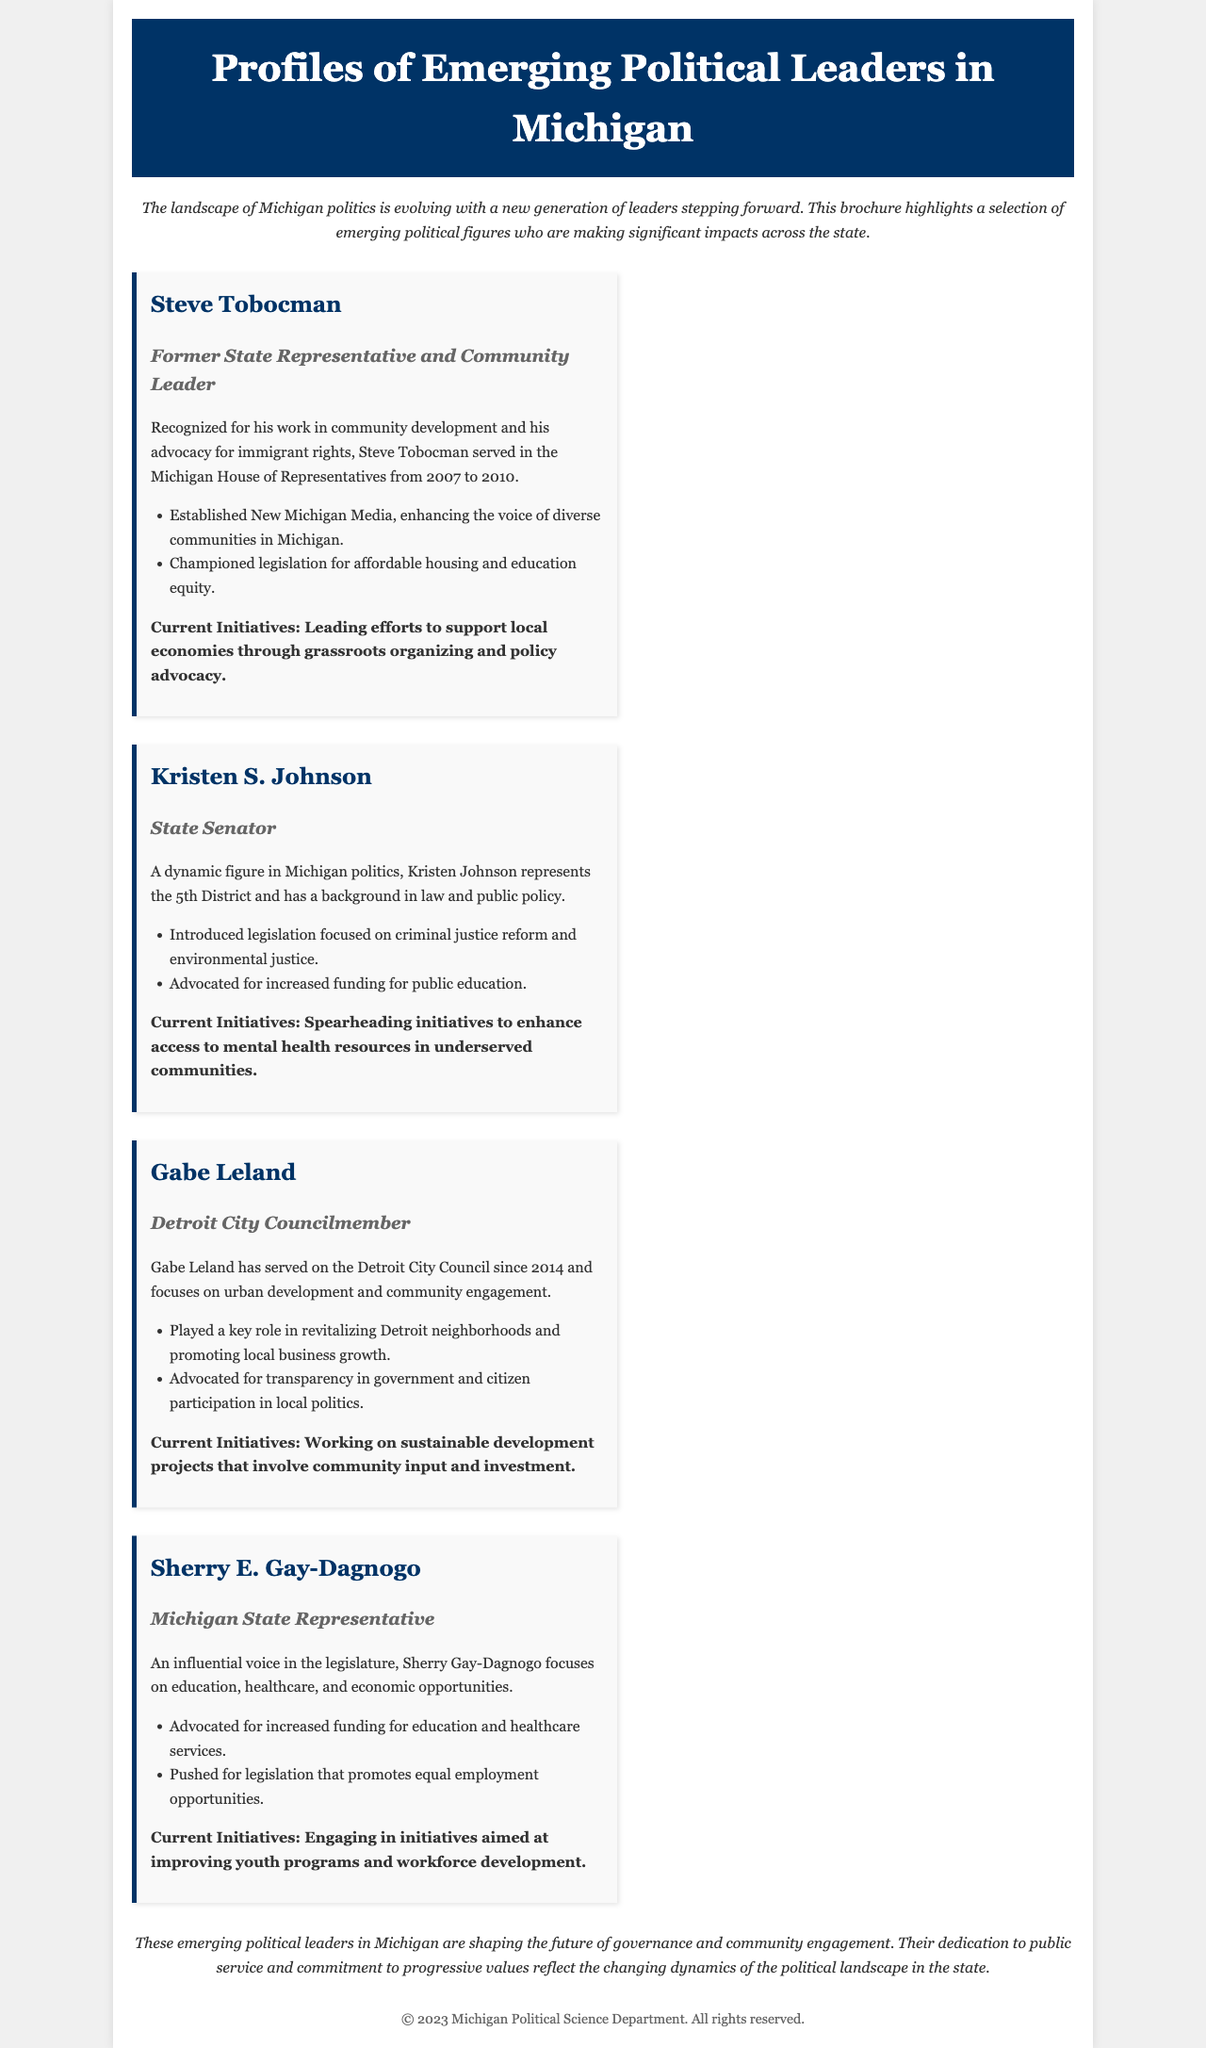What position did Steve Tobocman hold? Steve Tobocman served in the Michigan House of Representatives from 2007 to 2010.
Answer: State Representative What are Kristen S. Johnson's current initiatives? The brochure states that Kristen S. Johnson is spearheading initiatives to enhance access to mental health resources in underserved communities.
Answer: Enhancing access to mental health resources What community does Gabe Leland focus on? Gabe Leland focuses on urban development and community engagement.
Answer: Detroit What is Sherry E. Gay-Dagnogo's focus area in the legislature? Sherry E. Gay-Dagnogo focuses on education, healthcare, and economic opportunities.
Answer: Education, healthcare, and economic opportunities How many leaders are profiled in the brochure? Counting the leaders mentioned, there are four profiles provided in the brochure.
Answer: Four What advocacy group did Steve Tobocman establish? The document mentions that Steve Tobocman established New Michigan Media.
Answer: New Michigan Media What legislative focus is highlighted for Kristen S. Johnson? Kristen S. Johnson introduced legislation focused on criminal justice reform and environmental justice.
Answer: Criminal justice reform and environmental justice What is a key role Gabe Leland played in Detroit? Gabe Leland played a key role in revitalizing Detroit neighborhoods and promoting local business growth.
Answer: Revitalizing neighborhoods What does the brochure suggest about the future of Michigan governance? The brochure concludes by stating that these leaders are shaping the future of governance and community engagement.
Answer: Shaping the future of governance and community engagement 